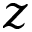<formula> <loc_0><loc_0><loc_500><loc_500>z</formula> 